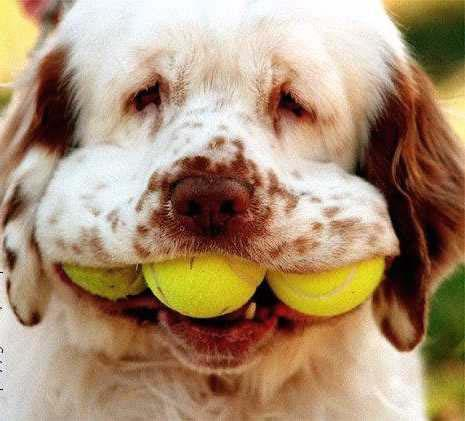What material is used to make the balls in the dogs mouth? Please explain your reasoning. rubber. Tennis balls are made of rubber in order to bounce effectively off the surface of a tennis court. 